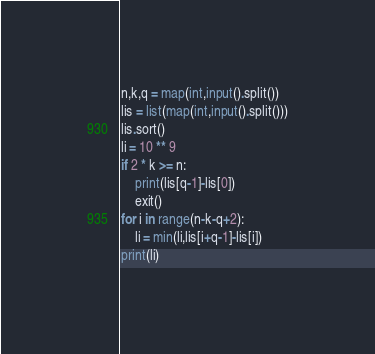Convert code to text. <code><loc_0><loc_0><loc_500><loc_500><_Python_>n,k,q = map(int,input().split())
lis = list(map(int,input().split()))
lis.sort()
li = 10 ** 9
if 2 * k >= n:
	print(lis[q-1]-lis[0])
	exit()
for i in range(n-k-q+2):
	li = min(li,lis[i+q-1]-lis[i])
print(li)</code> 